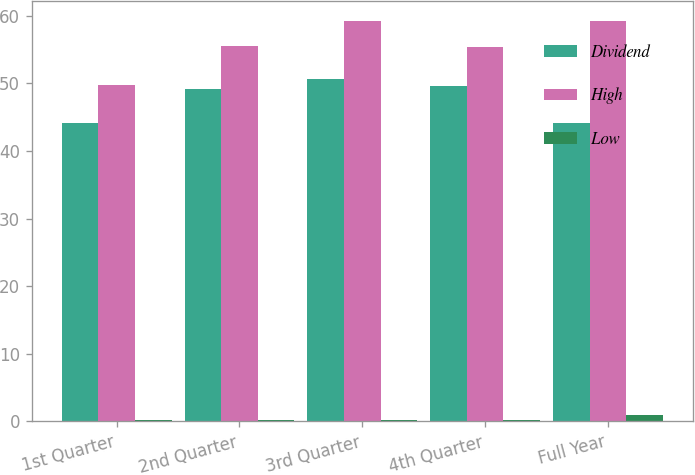Convert chart. <chart><loc_0><loc_0><loc_500><loc_500><stacked_bar_chart><ecel><fcel>1st Quarter<fcel>2nd Quarter<fcel>3rd Quarter<fcel>4th Quarter<fcel>Full Year<nl><fcel>Dividend<fcel>44.21<fcel>49.16<fcel>50.62<fcel>49.59<fcel>44.21<nl><fcel>High<fcel>49.74<fcel>55.5<fcel>59.27<fcel>55.42<fcel>59.27<nl><fcel>Low<fcel>0.24<fcel>0.24<fcel>0.24<fcel>0.24<fcel>0.96<nl></chart> 